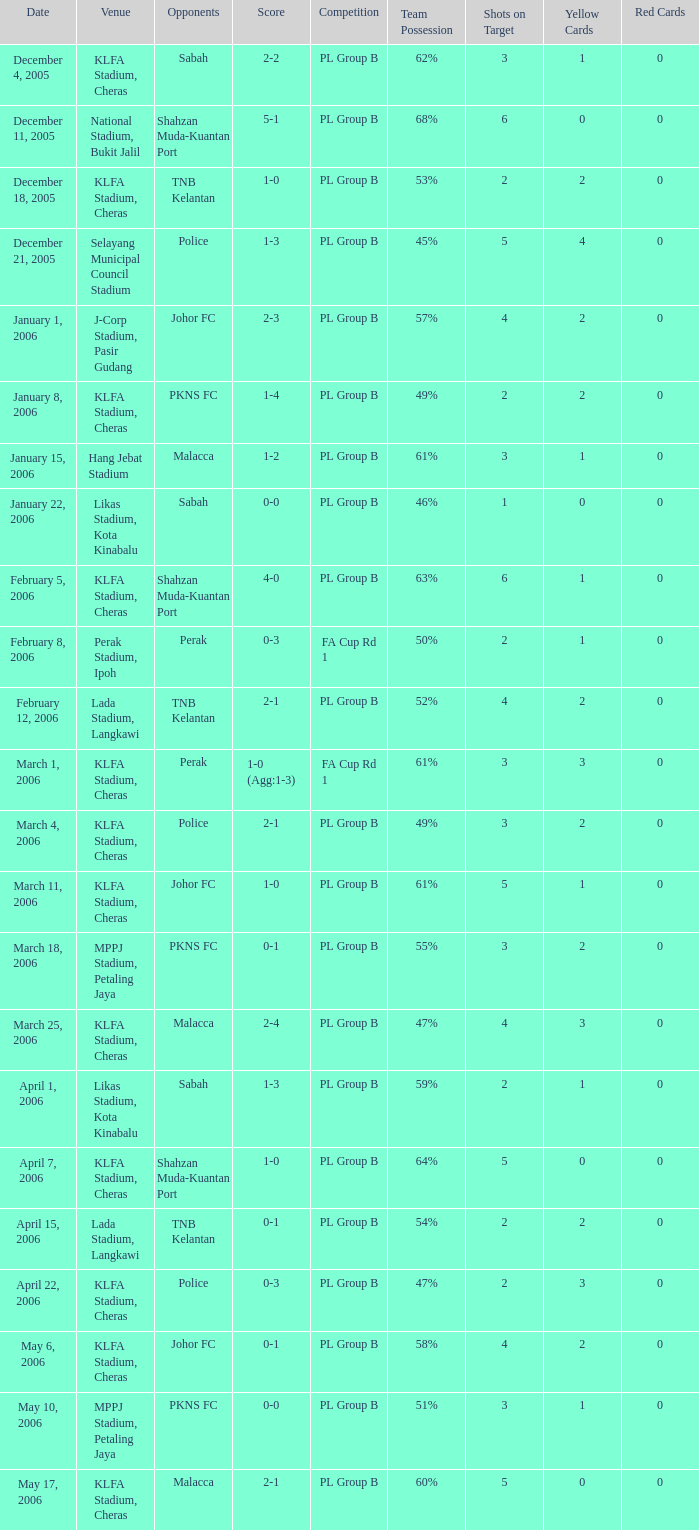Which Venue has a Competition of pl group b, and a Score of 2-2? KLFA Stadium, Cheras. Parse the table in full. {'header': ['Date', 'Venue', 'Opponents', 'Score', 'Competition', 'Team Possession', 'Shots on Target', 'Yellow Cards', 'Red Cards'], 'rows': [['December 4, 2005', 'KLFA Stadium, Cheras', 'Sabah', '2-2', 'PL Group B', '62%', '3', '1', '0'], ['December 11, 2005', 'National Stadium, Bukit Jalil', 'Shahzan Muda-Kuantan Port', '5-1', 'PL Group B', '68%', '6', '0', '0'], ['December 18, 2005', 'KLFA Stadium, Cheras', 'TNB Kelantan', '1-0', 'PL Group B', '53%', '2', '2', '0'], ['December 21, 2005', 'Selayang Municipal Council Stadium', 'Police', '1-3', 'PL Group B', '45%', '5', '4', '0'], ['January 1, 2006', 'J-Corp Stadium, Pasir Gudang', 'Johor FC', '2-3', 'PL Group B', '57%', '4', '2', '0'], ['January 8, 2006', 'KLFA Stadium, Cheras', 'PKNS FC', '1-4', 'PL Group B', '49%', '2', '2', '0'], ['January 15, 2006', 'Hang Jebat Stadium', 'Malacca', '1-2', 'PL Group B', '61%', '3', '1', '0'], ['January 22, 2006', 'Likas Stadium, Kota Kinabalu', 'Sabah', '0-0', 'PL Group B', '46%', '1', '0', '0'], ['February 5, 2006', 'KLFA Stadium, Cheras', 'Shahzan Muda-Kuantan Port', '4-0', 'PL Group B', '63%', '6', '1', '0'], ['February 8, 2006', 'Perak Stadium, Ipoh', 'Perak', '0-3', 'FA Cup Rd 1', '50%', '2', '1', '0'], ['February 12, 2006', 'Lada Stadium, Langkawi', 'TNB Kelantan', '2-1', 'PL Group B', '52%', '4', '2', '0'], ['March 1, 2006', 'KLFA Stadium, Cheras', 'Perak', '1-0 (Agg:1-3)', 'FA Cup Rd 1', '61%', '3', '3', '0'], ['March 4, 2006', 'KLFA Stadium, Cheras', 'Police', '2-1', 'PL Group B', '49%', '3', '2', '0'], ['March 11, 2006', 'KLFA Stadium, Cheras', 'Johor FC', '1-0', 'PL Group B', '61%', '5', '1', '0'], ['March 18, 2006', 'MPPJ Stadium, Petaling Jaya', 'PKNS FC', '0-1', 'PL Group B', '55%', '3', '2', '0'], ['March 25, 2006', 'KLFA Stadium, Cheras', 'Malacca', '2-4', 'PL Group B', '47%', '4', '3', '0'], ['April 1, 2006', 'Likas Stadium, Kota Kinabalu', 'Sabah', '1-3', 'PL Group B', '59%', '2', '1', '0'], ['April 7, 2006', 'KLFA Stadium, Cheras', 'Shahzan Muda-Kuantan Port', '1-0', 'PL Group B', '64%', '5', '0', '0'], ['April 15, 2006', 'Lada Stadium, Langkawi', 'TNB Kelantan', '0-1', 'PL Group B', '54%', '2', '2', '0'], ['April 22, 2006', 'KLFA Stadium, Cheras', 'Police', '0-3', 'PL Group B', '47%', '2', '3', '0'], ['May 6, 2006', 'KLFA Stadium, Cheras', 'Johor FC', '0-1', 'PL Group B', '58%', '4', '2', '0'], ['May 10, 2006', 'MPPJ Stadium, Petaling Jaya', 'PKNS FC', '0-0', 'PL Group B', '51%', '3', '1', '0'], ['May 17, 2006', 'KLFA Stadium, Cheras', 'Malacca', '2-1', 'PL Group B', '60%', '5', '0', '0']]} 